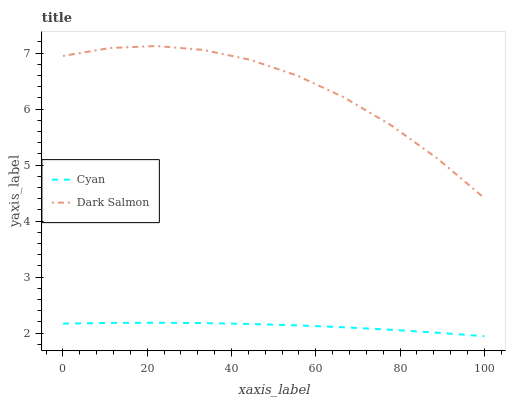Does Cyan have the minimum area under the curve?
Answer yes or no. Yes. Does Dark Salmon have the maximum area under the curve?
Answer yes or no. Yes. Does Dark Salmon have the minimum area under the curve?
Answer yes or no. No. Is Cyan the smoothest?
Answer yes or no. Yes. Is Dark Salmon the roughest?
Answer yes or no. Yes. Is Dark Salmon the smoothest?
Answer yes or no. No. Does Cyan have the lowest value?
Answer yes or no. Yes. Does Dark Salmon have the lowest value?
Answer yes or no. No. Does Dark Salmon have the highest value?
Answer yes or no. Yes. Is Cyan less than Dark Salmon?
Answer yes or no. Yes. Is Dark Salmon greater than Cyan?
Answer yes or no. Yes. Does Cyan intersect Dark Salmon?
Answer yes or no. No. 